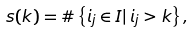<formula> <loc_0><loc_0><loc_500><loc_500>s ( k ) = \# \left \{ i _ { j } \in I | \, i _ { j } > k \right \} ,</formula> 